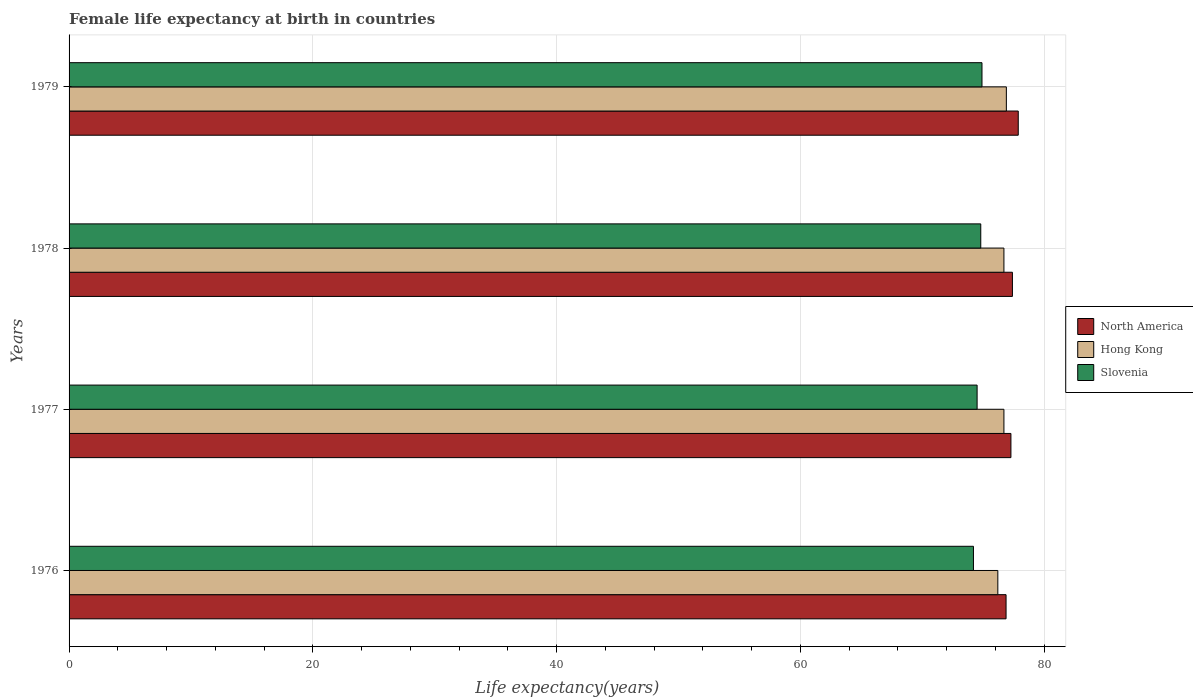How many groups of bars are there?
Make the answer very short. 4. Are the number of bars per tick equal to the number of legend labels?
Ensure brevity in your answer.  Yes. Are the number of bars on each tick of the Y-axis equal?
Your answer should be very brief. Yes. How many bars are there on the 1st tick from the top?
Ensure brevity in your answer.  3. What is the label of the 2nd group of bars from the top?
Offer a very short reply. 1978. What is the female life expectancy at birth in Slovenia in 1979?
Make the answer very short. 74.9. Across all years, what is the maximum female life expectancy at birth in Hong Kong?
Ensure brevity in your answer.  76.9. Across all years, what is the minimum female life expectancy at birth in Slovenia?
Your response must be concise. 74.2. In which year was the female life expectancy at birth in North America maximum?
Provide a short and direct response. 1979. In which year was the female life expectancy at birth in North America minimum?
Give a very brief answer. 1976. What is the total female life expectancy at birth in Slovenia in the graph?
Offer a terse response. 298.4. What is the difference between the female life expectancy at birth in North America in 1978 and that in 1979?
Give a very brief answer. -0.48. What is the difference between the female life expectancy at birth in Hong Kong in 1979 and the female life expectancy at birth in North America in 1977?
Give a very brief answer. -0.37. What is the average female life expectancy at birth in Hong Kong per year?
Your answer should be compact. 76.62. In the year 1979, what is the difference between the female life expectancy at birth in Hong Kong and female life expectancy at birth in North America?
Your answer should be compact. -0.98. What is the ratio of the female life expectancy at birth in North America in 1977 to that in 1978?
Provide a succinct answer. 1. Is the difference between the female life expectancy at birth in Hong Kong in 1977 and 1978 greater than the difference between the female life expectancy at birth in North America in 1977 and 1978?
Your response must be concise. Yes. What is the difference between the highest and the second highest female life expectancy at birth in Hong Kong?
Make the answer very short. 0.2. What is the difference between the highest and the lowest female life expectancy at birth in Slovenia?
Keep it short and to the point. 0.7. In how many years, is the female life expectancy at birth in Hong Kong greater than the average female life expectancy at birth in Hong Kong taken over all years?
Keep it short and to the point. 3. Is the sum of the female life expectancy at birth in North America in 1977 and 1978 greater than the maximum female life expectancy at birth in Hong Kong across all years?
Your answer should be compact. Yes. What does the 2nd bar from the top in 1976 represents?
Offer a very short reply. Hong Kong. What does the 2nd bar from the bottom in 1978 represents?
Provide a succinct answer. Hong Kong. How many years are there in the graph?
Your answer should be compact. 4. What is the difference between two consecutive major ticks on the X-axis?
Make the answer very short. 20. Are the values on the major ticks of X-axis written in scientific E-notation?
Offer a terse response. No. Does the graph contain grids?
Offer a very short reply. Yes. How are the legend labels stacked?
Your response must be concise. Vertical. What is the title of the graph?
Offer a terse response. Female life expectancy at birth in countries. What is the label or title of the X-axis?
Offer a very short reply. Life expectancy(years). What is the Life expectancy(years) in North America in 1976?
Your answer should be compact. 76.88. What is the Life expectancy(years) in Hong Kong in 1976?
Give a very brief answer. 76.2. What is the Life expectancy(years) in Slovenia in 1976?
Ensure brevity in your answer.  74.2. What is the Life expectancy(years) of North America in 1977?
Offer a terse response. 77.27. What is the Life expectancy(years) in Hong Kong in 1977?
Ensure brevity in your answer.  76.7. What is the Life expectancy(years) of Slovenia in 1977?
Your answer should be compact. 74.5. What is the Life expectancy(years) in North America in 1978?
Make the answer very short. 77.4. What is the Life expectancy(years) in Hong Kong in 1978?
Your answer should be compact. 76.7. What is the Life expectancy(years) in Slovenia in 1978?
Offer a terse response. 74.8. What is the Life expectancy(years) in North America in 1979?
Offer a very short reply. 77.88. What is the Life expectancy(years) in Hong Kong in 1979?
Give a very brief answer. 76.9. What is the Life expectancy(years) in Slovenia in 1979?
Offer a very short reply. 74.9. Across all years, what is the maximum Life expectancy(years) of North America?
Keep it short and to the point. 77.88. Across all years, what is the maximum Life expectancy(years) of Hong Kong?
Your answer should be compact. 76.9. Across all years, what is the maximum Life expectancy(years) of Slovenia?
Provide a succinct answer. 74.9. Across all years, what is the minimum Life expectancy(years) of North America?
Your answer should be compact. 76.88. Across all years, what is the minimum Life expectancy(years) of Hong Kong?
Your response must be concise. 76.2. Across all years, what is the minimum Life expectancy(years) of Slovenia?
Ensure brevity in your answer.  74.2. What is the total Life expectancy(years) in North America in the graph?
Give a very brief answer. 309.42. What is the total Life expectancy(years) in Hong Kong in the graph?
Offer a terse response. 306.5. What is the total Life expectancy(years) in Slovenia in the graph?
Make the answer very short. 298.4. What is the difference between the Life expectancy(years) of North America in 1976 and that in 1977?
Your response must be concise. -0.4. What is the difference between the Life expectancy(years) in North America in 1976 and that in 1978?
Offer a very short reply. -0.52. What is the difference between the Life expectancy(years) in Hong Kong in 1976 and that in 1978?
Your answer should be compact. -0.5. What is the difference between the Life expectancy(years) of Slovenia in 1976 and that in 1978?
Provide a succinct answer. -0.6. What is the difference between the Life expectancy(years) of North America in 1976 and that in 1979?
Your answer should be compact. -1. What is the difference between the Life expectancy(years) of Hong Kong in 1976 and that in 1979?
Give a very brief answer. -0.7. What is the difference between the Life expectancy(years) in Slovenia in 1976 and that in 1979?
Your answer should be very brief. -0.7. What is the difference between the Life expectancy(years) in North America in 1977 and that in 1978?
Provide a short and direct response. -0.12. What is the difference between the Life expectancy(years) in Hong Kong in 1977 and that in 1978?
Provide a short and direct response. 0. What is the difference between the Life expectancy(years) of North America in 1977 and that in 1979?
Give a very brief answer. -0.6. What is the difference between the Life expectancy(years) of North America in 1978 and that in 1979?
Provide a short and direct response. -0.48. What is the difference between the Life expectancy(years) in Hong Kong in 1978 and that in 1979?
Provide a short and direct response. -0.2. What is the difference between the Life expectancy(years) of Slovenia in 1978 and that in 1979?
Give a very brief answer. -0.1. What is the difference between the Life expectancy(years) in North America in 1976 and the Life expectancy(years) in Hong Kong in 1977?
Provide a succinct answer. 0.18. What is the difference between the Life expectancy(years) of North America in 1976 and the Life expectancy(years) of Slovenia in 1977?
Your answer should be very brief. 2.38. What is the difference between the Life expectancy(years) in North America in 1976 and the Life expectancy(years) in Hong Kong in 1978?
Provide a short and direct response. 0.18. What is the difference between the Life expectancy(years) of North America in 1976 and the Life expectancy(years) of Slovenia in 1978?
Ensure brevity in your answer.  2.08. What is the difference between the Life expectancy(years) in North America in 1976 and the Life expectancy(years) in Hong Kong in 1979?
Offer a very short reply. -0.02. What is the difference between the Life expectancy(years) of North America in 1976 and the Life expectancy(years) of Slovenia in 1979?
Ensure brevity in your answer.  1.98. What is the difference between the Life expectancy(years) of Hong Kong in 1976 and the Life expectancy(years) of Slovenia in 1979?
Your answer should be compact. 1.3. What is the difference between the Life expectancy(years) of North America in 1977 and the Life expectancy(years) of Hong Kong in 1978?
Provide a short and direct response. 0.57. What is the difference between the Life expectancy(years) in North America in 1977 and the Life expectancy(years) in Slovenia in 1978?
Your response must be concise. 2.47. What is the difference between the Life expectancy(years) in North America in 1977 and the Life expectancy(years) in Hong Kong in 1979?
Your answer should be very brief. 0.37. What is the difference between the Life expectancy(years) in North America in 1977 and the Life expectancy(years) in Slovenia in 1979?
Your answer should be very brief. 2.37. What is the difference between the Life expectancy(years) in North America in 1978 and the Life expectancy(years) in Hong Kong in 1979?
Your answer should be compact. 0.5. What is the difference between the Life expectancy(years) in North America in 1978 and the Life expectancy(years) in Slovenia in 1979?
Your response must be concise. 2.5. What is the average Life expectancy(years) of North America per year?
Make the answer very short. 77.36. What is the average Life expectancy(years) of Hong Kong per year?
Provide a succinct answer. 76.62. What is the average Life expectancy(years) of Slovenia per year?
Offer a very short reply. 74.6. In the year 1976, what is the difference between the Life expectancy(years) of North America and Life expectancy(years) of Hong Kong?
Your answer should be compact. 0.68. In the year 1976, what is the difference between the Life expectancy(years) of North America and Life expectancy(years) of Slovenia?
Offer a very short reply. 2.68. In the year 1977, what is the difference between the Life expectancy(years) in North America and Life expectancy(years) in Hong Kong?
Your answer should be compact. 0.57. In the year 1977, what is the difference between the Life expectancy(years) in North America and Life expectancy(years) in Slovenia?
Your answer should be compact. 2.77. In the year 1977, what is the difference between the Life expectancy(years) in Hong Kong and Life expectancy(years) in Slovenia?
Provide a short and direct response. 2.2. In the year 1978, what is the difference between the Life expectancy(years) in North America and Life expectancy(years) in Hong Kong?
Your response must be concise. 0.7. In the year 1978, what is the difference between the Life expectancy(years) of North America and Life expectancy(years) of Slovenia?
Provide a short and direct response. 2.6. In the year 1979, what is the difference between the Life expectancy(years) in North America and Life expectancy(years) in Hong Kong?
Your answer should be very brief. 0.98. In the year 1979, what is the difference between the Life expectancy(years) in North America and Life expectancy(years) in Slovenia?
Provide a short and direct response. 2.98. What is the ratio of the Life expectancy(years) in North America in 1976 to that in 1977?
Provide a short and direct response. 0.99. What is the ratio of the Life expectancy(years) in Slovenia in 1976 to that in 1978?
Your answer should be compact. 0.99. What is the ratio of the Life expectancy(years) of North America in 1976 to that in 1979?
Your response must be concise. 0.99. What is the ratio of the Life expectancy(years) of Hong Kong in 1976 to that in 1979?
Give a very brief answer. 0.99. What is the ratio of the Life expectancy(years) in North America in 1977 to that in 1978?
Ensure brevity in your answer.  1. What is the ratio of the Life expectancy(years) of Hong Kong in 1977 to that in 1978?
Make the answer very short. 1. What is the ratio of the Life expectancy(years) of Slovenia in 1977 to that in 1979?
Offer a very short reply. 0.99. What is the ratio of the Life expectancy(years) of North America in 1978 to that in 1979?
Your answer should be very brief. 0.99. What is the ratio of the Life expectancy(years) in Hong Kong in 1978 to that in 1979?
Ensure brevity in your answer.  1. What is the difference between the highest and the second highest Life expectancy(years) in North America?
Ensure brevity in your answer.  0.48. What is the difference between the highest and the second highest Life expectancy(years) in Slovenia?
Provide a short and direct response. 0.1. 